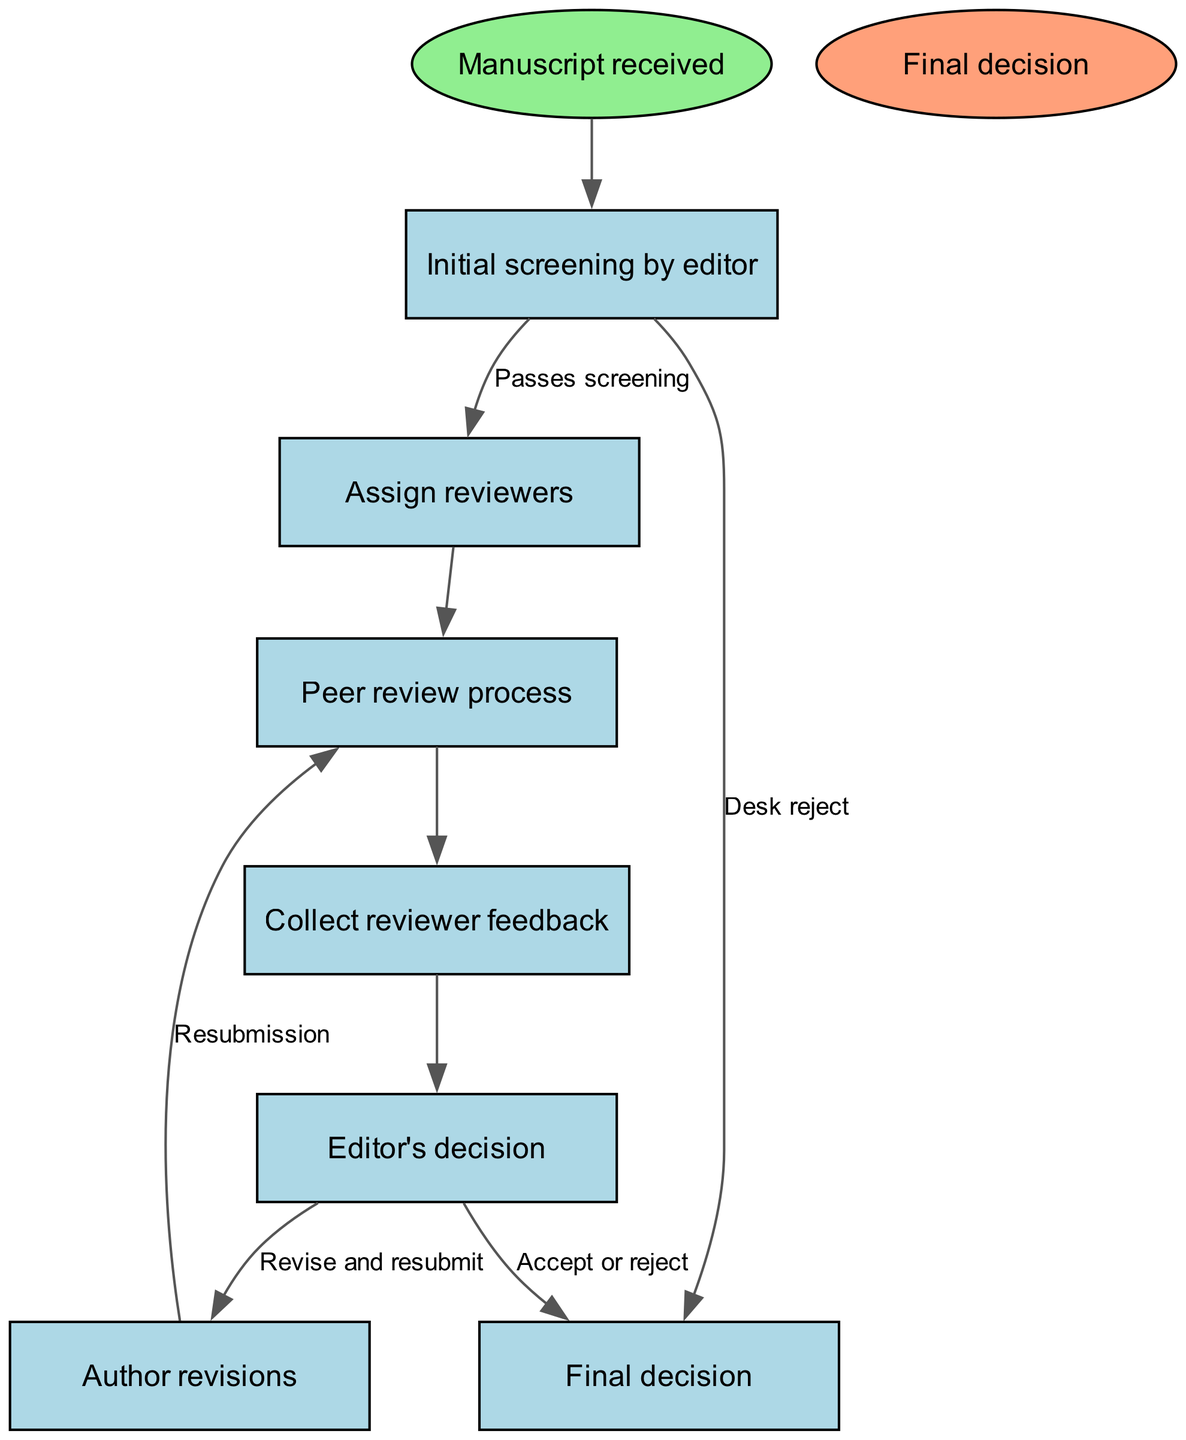What is the first step in the peer review process? The first step is "Manuscript received," which is indicated as the start node in the flow chart. This is where the entire process begins when a manuscript is submitted.
Answer: Manuscript received How many nodes are present in the diagram? The diagram includes a total of 7 nodes: "Manuscript received," "Initial screening by editor," "Assign reviewers," "Peer review process," "Collect reviewer feedback," "Editor's decision," "Author revisions," and "Final decision." Counting these gives a total of 8 nodes.
Answer: 8 What happens if the manuscript fails the initial screening? If the manuscript fails the initial screening, it is labeled as a "Desk reject," which leads directly to the "Final decision" node as indicated in the edge connections.
Answer: Desk reject What action follows after the editor's decision if the manuscript is to be revised? Following the editor's decision to "Revise and resubmit," the next action is for the authors to make "Author revisions," as shown by the edge from "Editor's decision" to "Author revisions."
Answer: Author revisions How many edges are there leading from the "Editor's decision" node? There are two edges leading from "Editor's decision": one to "Author revisions" and another to "Final decision." These signify the two possible actions after the editor's review.
Answer: 2 What is the label on the edge leading from "Initial screening by editor" to "Assign reviewers"? The label on this edge is "Passes screening," indicating that only those manuscripts passing the initial screening are assigned to reviewers.
Answer: Passes screening If a manuscript is resubmitted after revisions, which node does it go back to? A resubmitted manuscript goes back to the "Peer review process" node, as indicated by the directed edge connecting "Author revisions" to "Peer review process."
Answer: Peer review process What is the final outcome of the entire process depicted in the flowchart? The final outcome of the peer review process is represented by the "Final decision" node, where the manuscript is either accepted or rejected.
Answer: Final decision 